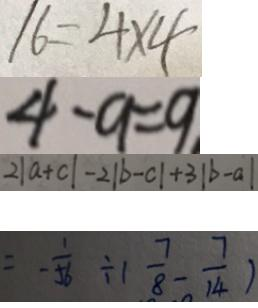Convert formula to latex. <formula><loc_0><loc_0><loc_500><loc_500>1 6 = 4 \times 4 
 4 - 9 = 9 
 2 \vert a + c \vert - 2 \vert b - c \vert + 3 \vert b - a \vert 
 = - \frac { 1 } { 5 6 } \div ( \frac { 7 } { 8 } - \frac { 7 } { 1 4 } )</formula> 